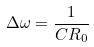<formula> <loc_0><loc_0><loc_500><loc_500>\Delta \omega = \frac { 1 } { C R _ { 0 } }</formula> 